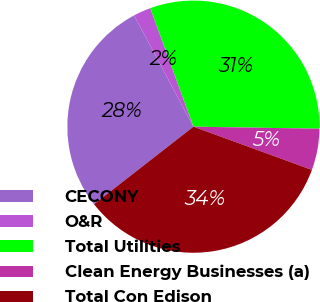<chart> <loc_0><loc_0><loc_500><loc_500><pie_chart><fcel>CECONY<fcel>O&R<fcel>Total Utilities<fcel>Clean Energy Businesses (a)<fcel>Total Con Edison<nl><fcel>27.74%<fcel>2.24%<fcel>30.82%<fcel>5.31%<fcel>33.89%<nl></chart> 